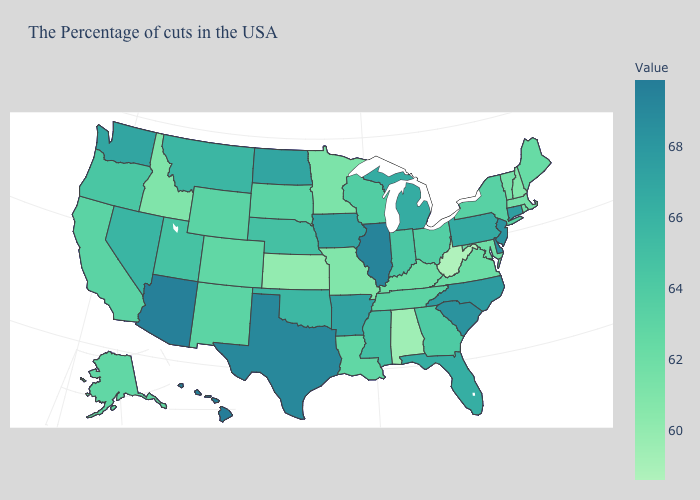Which states have the highest value in the USA?
Keep it brief. Hawaii. Which states have the lowest value in the USA?
Concise answer only. West Virginia. Does Wisconsin have a lower value than Mississippi?
Give a very brief answer. Yes. 